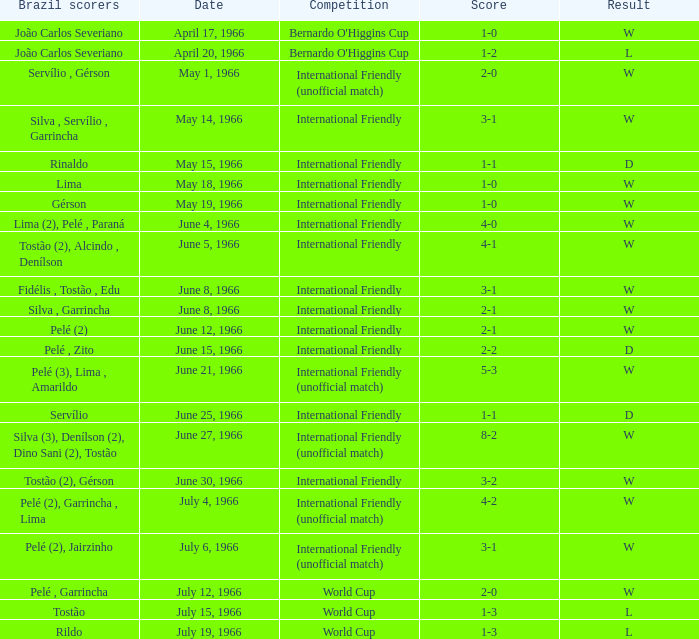What is the result when the score is 4-0? W. 